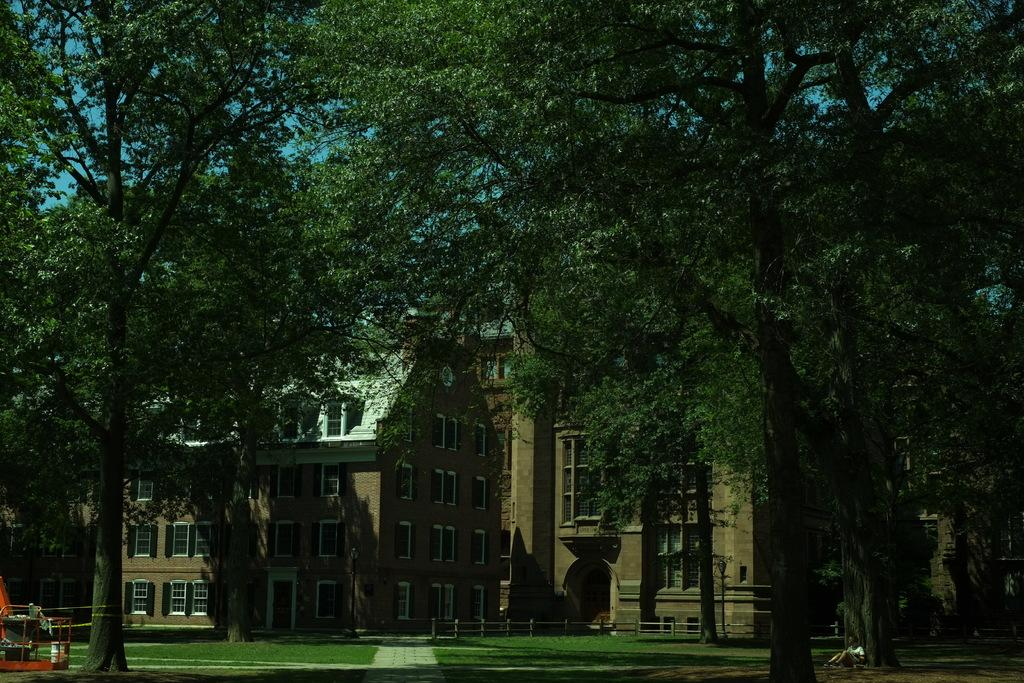What type of vegetation is at the bottom of the image? There are trees at the bottom of the image. What structure can be seen in the background of the image? There is a building in the background of the image. Where is the person sitting in the image? The person is sitting on a grassy land in the bottom right corner of the image. What type of quill is the person holding in the image? There is no quill present in the image; the person is simply sitting on the grassy land. How many friends is the person with in the image? The image only shows one person, so there are no friends present. 